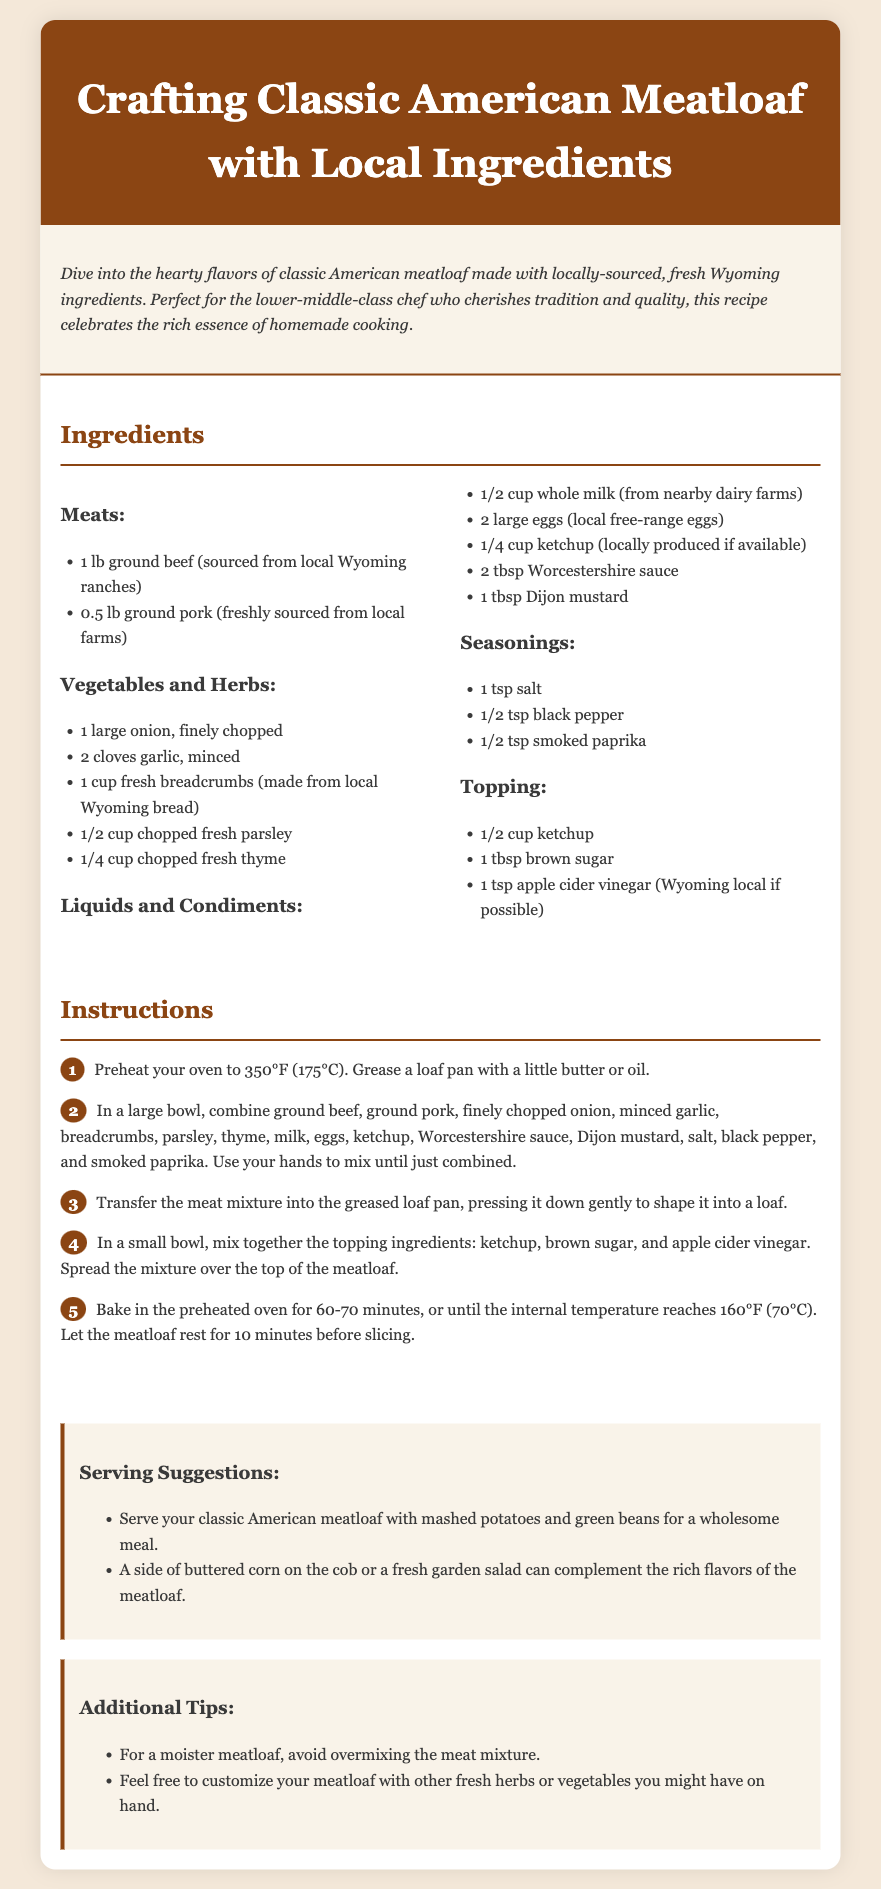What type of meat is used in the recipe? The document specifies the types of meat used in the meatloaf recipe, which are ground beef and ground pork.
Answer: ground beef, ground pork How many cloves of garlic are needed? The ingredients list mentions the amount of garlic required for the recipe, which is specifically given as two cloves.
Answer: 2 cloves What temperature should the oven be preheated to? The instructions detail the oven temperature necessary for baking the meatloaf, which is stated in Fahrenheit.
Answer: 350°F What is the volume of whole milk required? The ingredients list specifies the quantity of whole milk needed for the recipe, which is one half of a cup.
Answer: 1/2 cup What herb is mentioned for the topping? The document specifies that apple cider vinegar is included in the topping ingredients for the meatloaf.
Answer: apple cider vinegar Which two vegetables are listed in the meatloaf? The ingredients section identifies onion and garlic as vegetables included in the recipe.
Answer: onion, garlic What is the baking time for the meatloaf? The instructions provide a baking duration for the meatloaf, indicating it should be baked for 60 to 70 minutes.
Answer: 60-70 minutes What is a suggested side dish for serving? The serving suggestions outline a side dish that pairs well with the meatloaf, specifically naming mashed potatoes.
Answer: mashed potatoes 